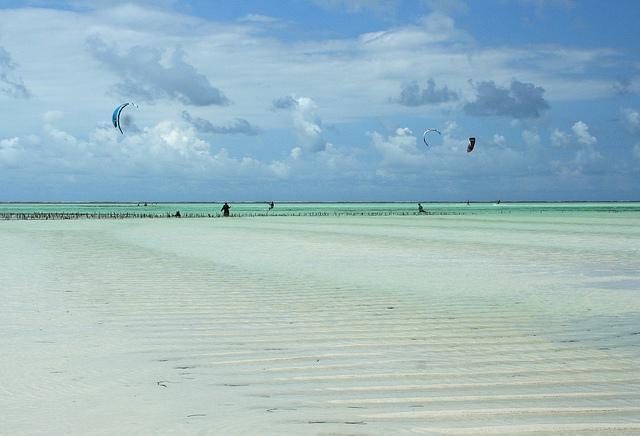How many kites are there?
Give a very brief answer. 3. 